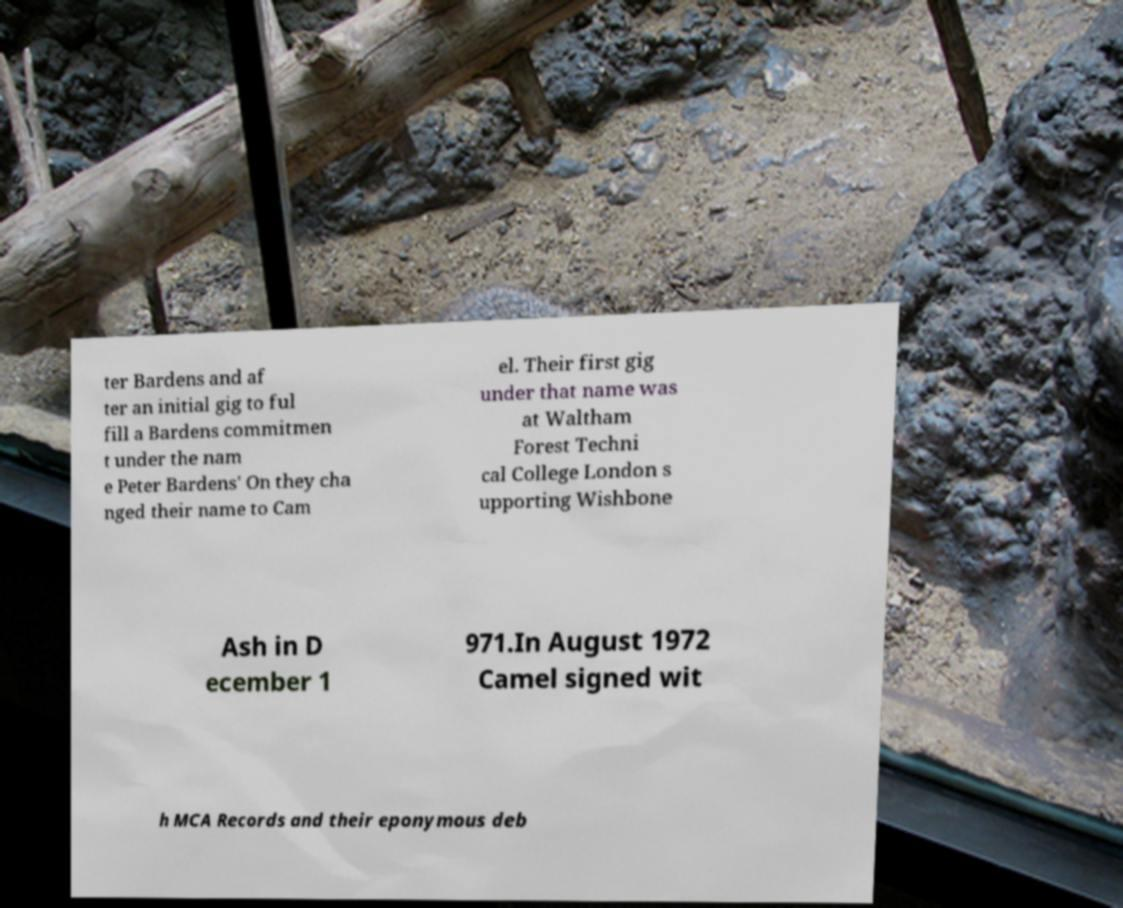I need the written content from this picture converted into text. Can you do that? ter Bardens and af ter an initial gig to ful fill a Bardens commitmen t under the nam e Peter Bardens' On they cha nged their name to Cam el. Their first gig under that name was at Waltham Forest Techni cal College London s upporting Wishbone Ash in D ecember 1 971.In August 1972 Camel signed wit h MCA Records and their eponymous deb 